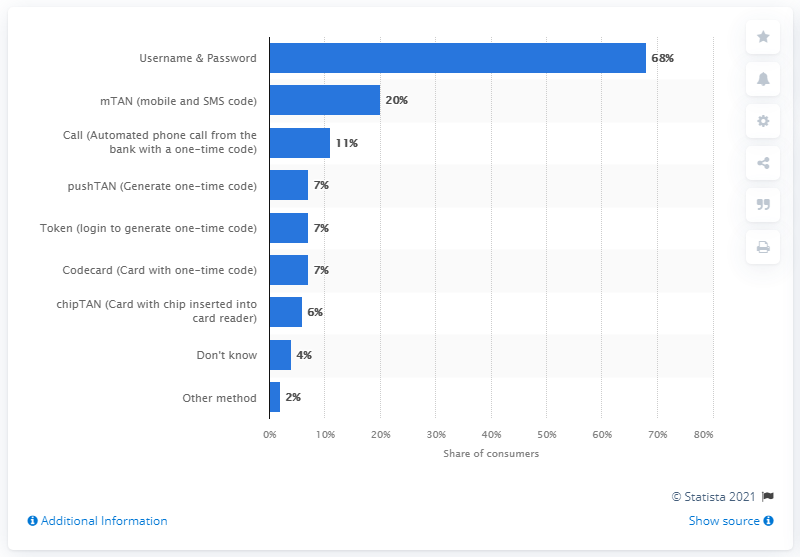Mention a couple of crucial points in this snapshot. According to the data, the most popular method of logging into online banking among consumers was used by 68% of them. 